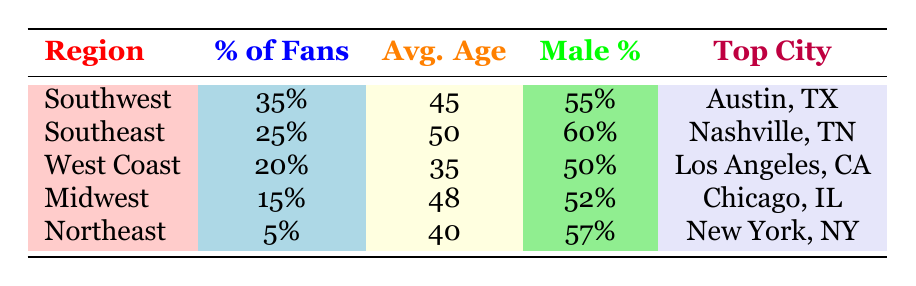What percentage of the fanbase is from the Southwest region? The table shows that the Southwest region has a percentage of fans listed as 35% under the column for % of Fans.
Answer: 35% Which region has the highest percentage of male fans? In the gender distribution column, the Southeast has 60% male fans, which is higher than any other region's male percentage.
Answer: Southeast What is the average age of fans in the West Coast region? The table indicates that the average age for the West Coast is 35, found in the Avg. Age column.
Answer: 35 What is the average percentage of fans from the Midwest and Northeast regions combined? The percentage of fans for the Midwest is 15% and for the Northeast is 5%. Summing these gives 15 + 5 = 20%. Now, to find the average, divide by 2 which gives 20% / 2 = 10%.
Answer: 10% Is it true that the Northeast region has a higher average age than the Midwest region? The average age in the Northeast is 40 while in the Midwest it is 48. Since 40 is less than 48, this statement is false.
Answer: No What is the top city for fans from the Southeast region? By looking at the Top City column for the Southeast region, it lists Nashville, TN as the top city.
Answer: Nashville, TN Which region has the oldest average age among Willie Nelson fans, and what is that age? From the table, the Southeast region has the oldest average age at 50, which is the highest average age listed compared to other regions.
Answer: Southeast, 50 What percentage of fans is from regions other than the Southwest? The total percentage of fans from the Southwest is 35%, so the rest would be 100% - 35% = 65%. This totals the percentages from the Southeast, West Coast, Midwest, and Northeast regions.
Answer: 65% 